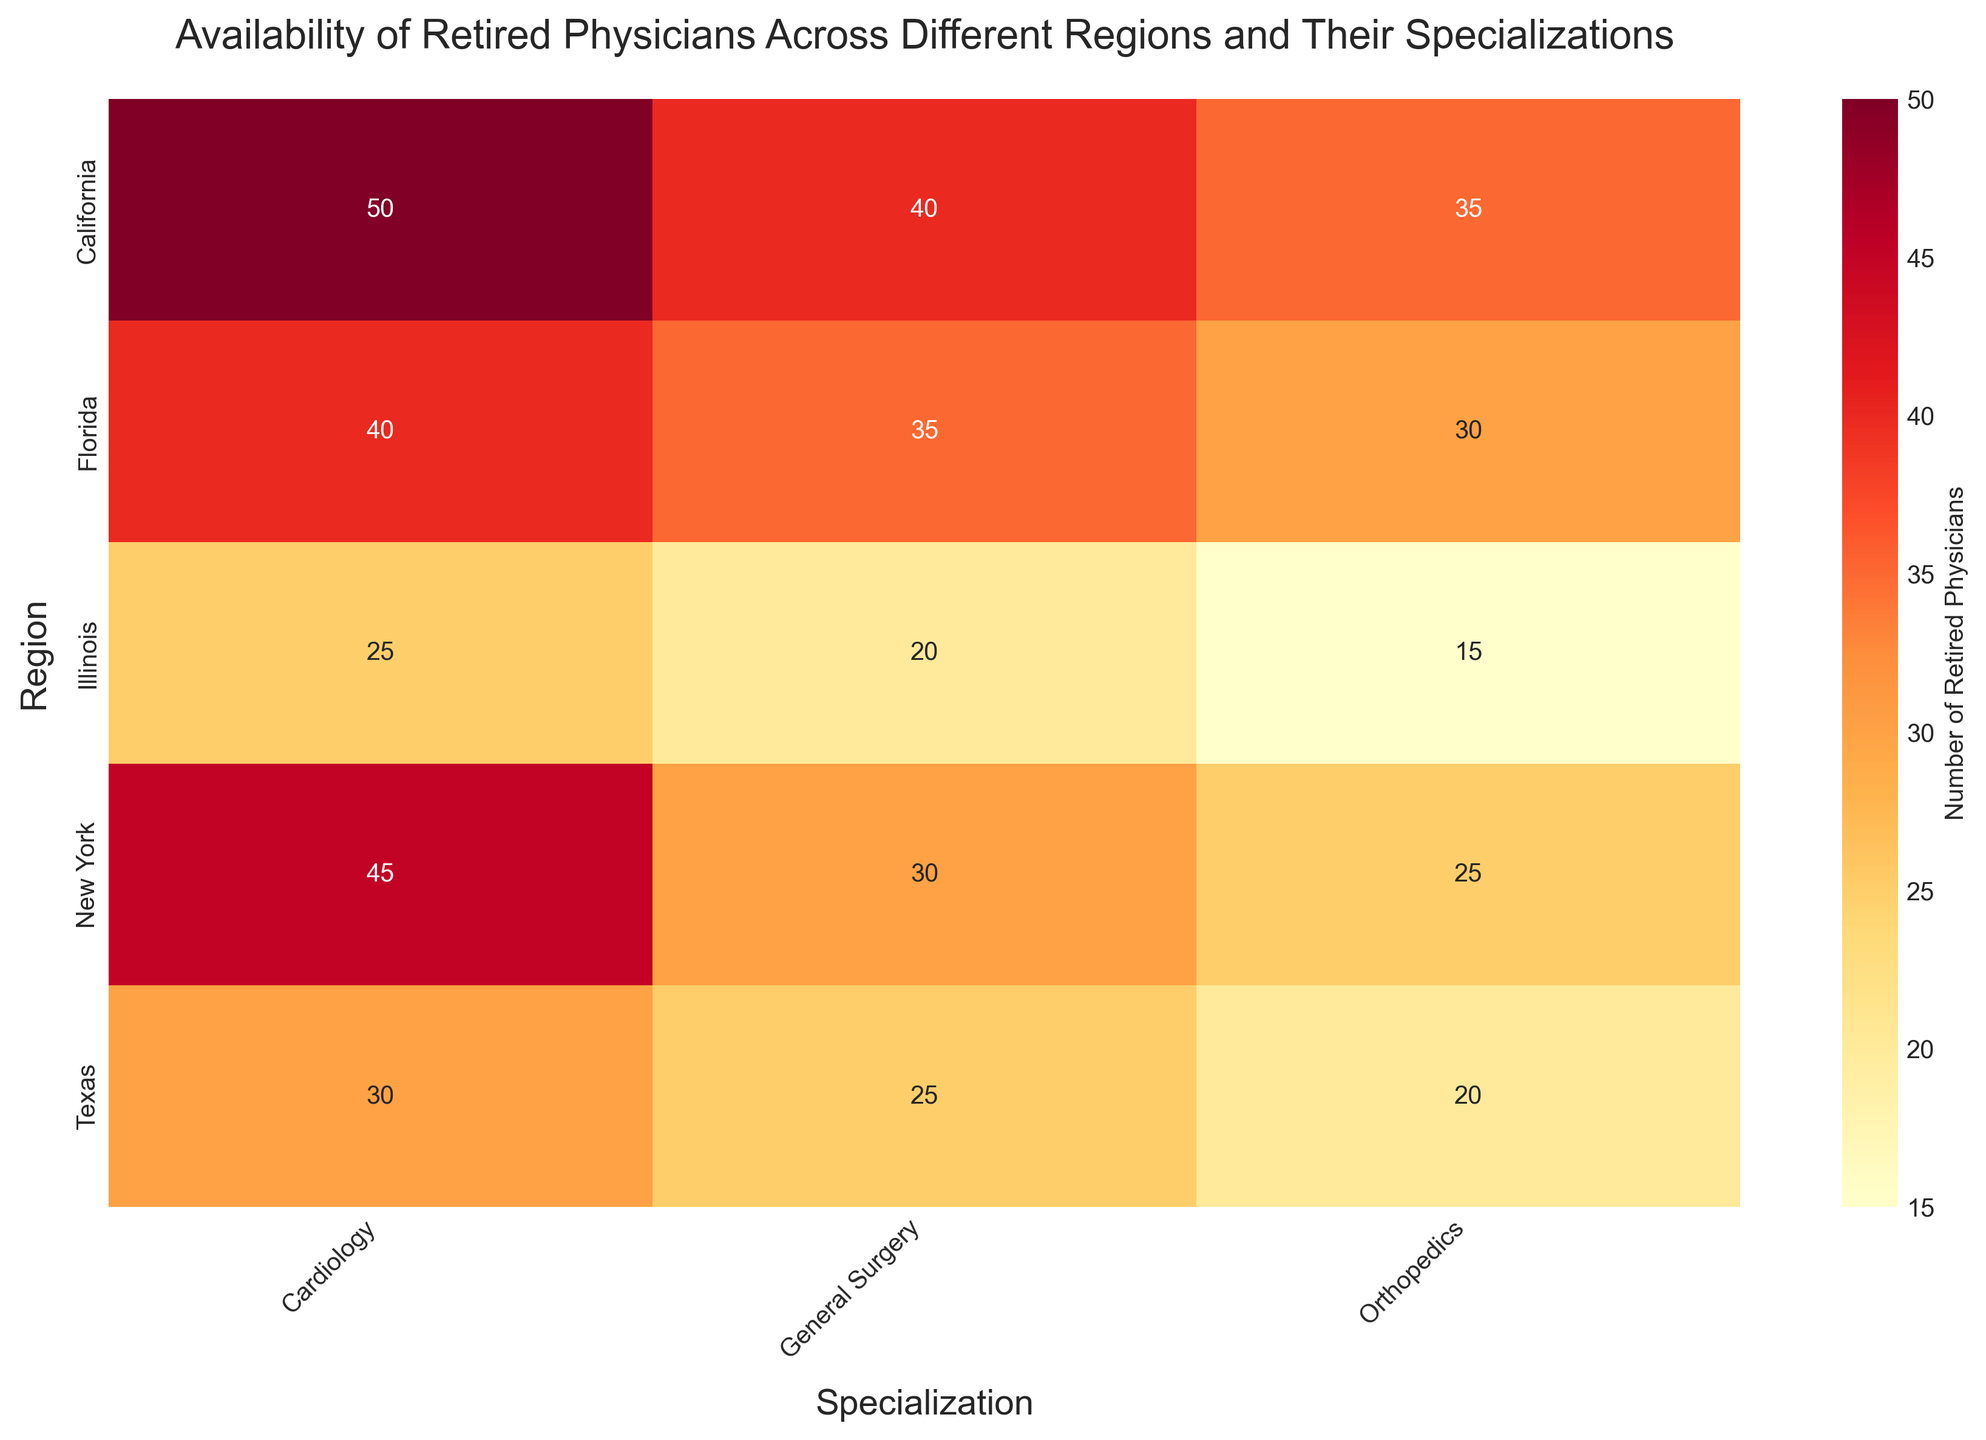What region has the highest number of retired cardiologists? Look at the cardiology column and identify the maximum value. The highest value is 50 in California.
Answer: California What is the total number of retired physicians in New York across all specializations? Sum the values for New York: 45 (Cardiology) + 30 (General Surgery) + 25 (Orthopedics) = 100
Answer: 100 Which specialization has the least number of retired physicians in Texas? Compare the values in the Texas row. The smallest value is 20 in Orthopedics.
Answer: Orthopedics How many more retired cardiologists are there in California than in Illinois? Subtract the number of retired cardiologists in Illinois from the number in California: 50 - 25 = 25
Answer: 25 Which region has the highest number of retired orthopedic surgeons? Look at the orthopedics column and identify the maximum value. The highest value is 35 in California.
Answer: California What is the average number of retired general surgeons across all regions? Sum the values in the general surgery column and divide by the number of regions: (30 + 40 + 25 + 35 + 20) / 5 = 30
Answer: 30 Is the number of retired physicians in Florida higher for orthopedics or general surgery? Compare the values in Florida's row for Orthopedics (30) and General Surgery (35). General Surgery has a higher number.
Answer: General Surgery Which region has the fewest retired physicians across all specializations, and what is this total? Sum the values for each region, and find the region with the smallest total. Illinois: 25 (Cardiology) + 20 (General Surgery) + 15 (Orthopedics) = 60, which is the smallest total.
Answer: Illinois, 60 